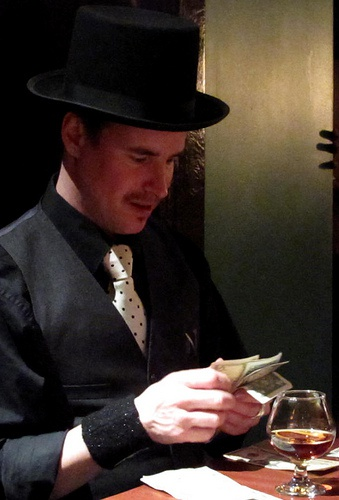Describe the objects in this image and their specific colors. I can see people in black, maroon, white, and gray tones, wine glass in black, maroon, and gray tones, dining table in black, salmon, brown, and maroon tones, and tie in black, gray, and lightgray tones in this image. 